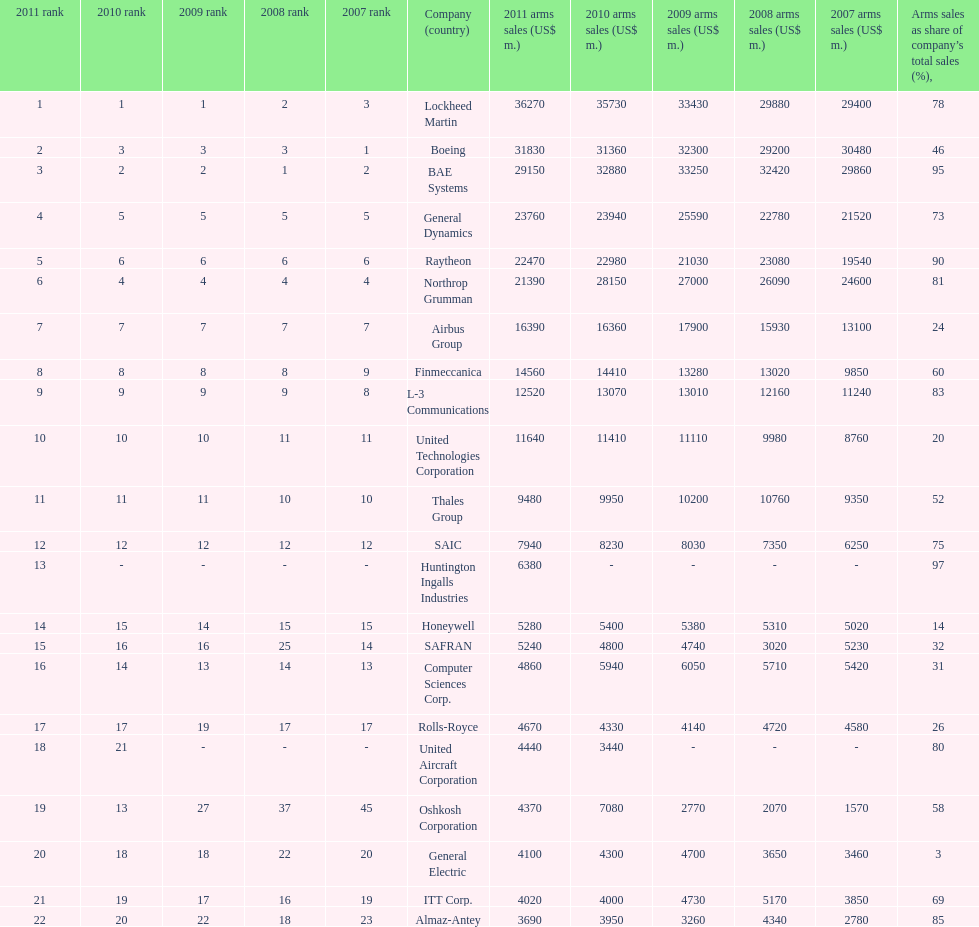How many companies are under the united states? 14. 